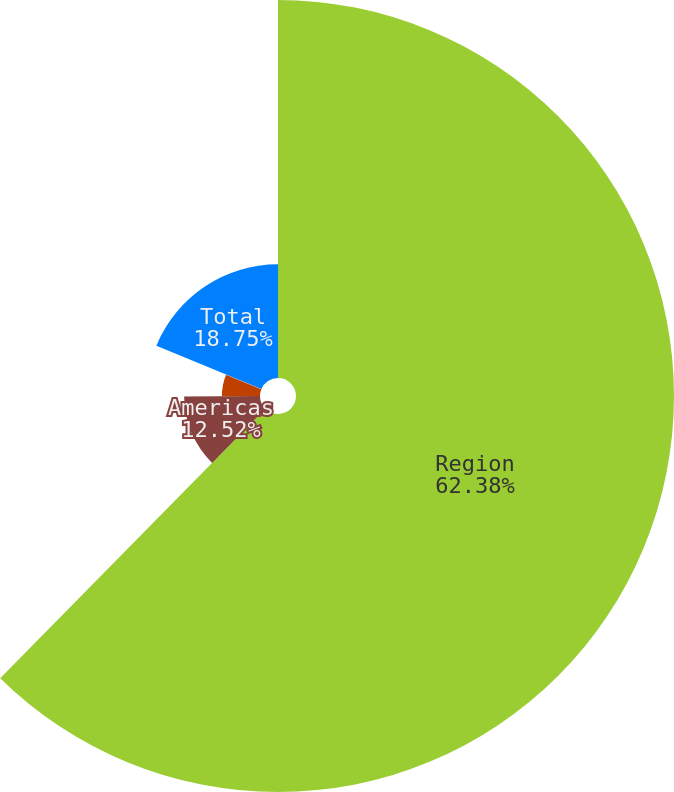<chart> <loc_0><loc_0><loc_500><loc_500><pie_chart><fcel>Region<fcel>Americas<fcel>EMEA<fcel>Asia<fcel>Total<nl><fcel>62.37%<fcel>12.52%<fcel>6.29%<fcel>0.06%<fcel>18.75%<nl></chart> 